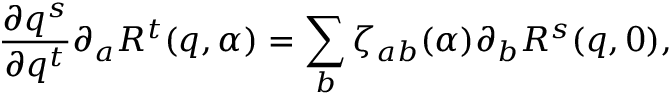Convert formula to latex. <formula><loc_0><loc_0><loc_500><loc_500>\frac { \partial q ^ { s } } { \partial q ^ { t } } \partial _ { a } R ^ { t } ( q , \alpha ) = \sum _ { b } \zeta _ { a b } ( \alpha ) \partial _ { b } R ^ { s } ( q , 0 ) ,</formula> 